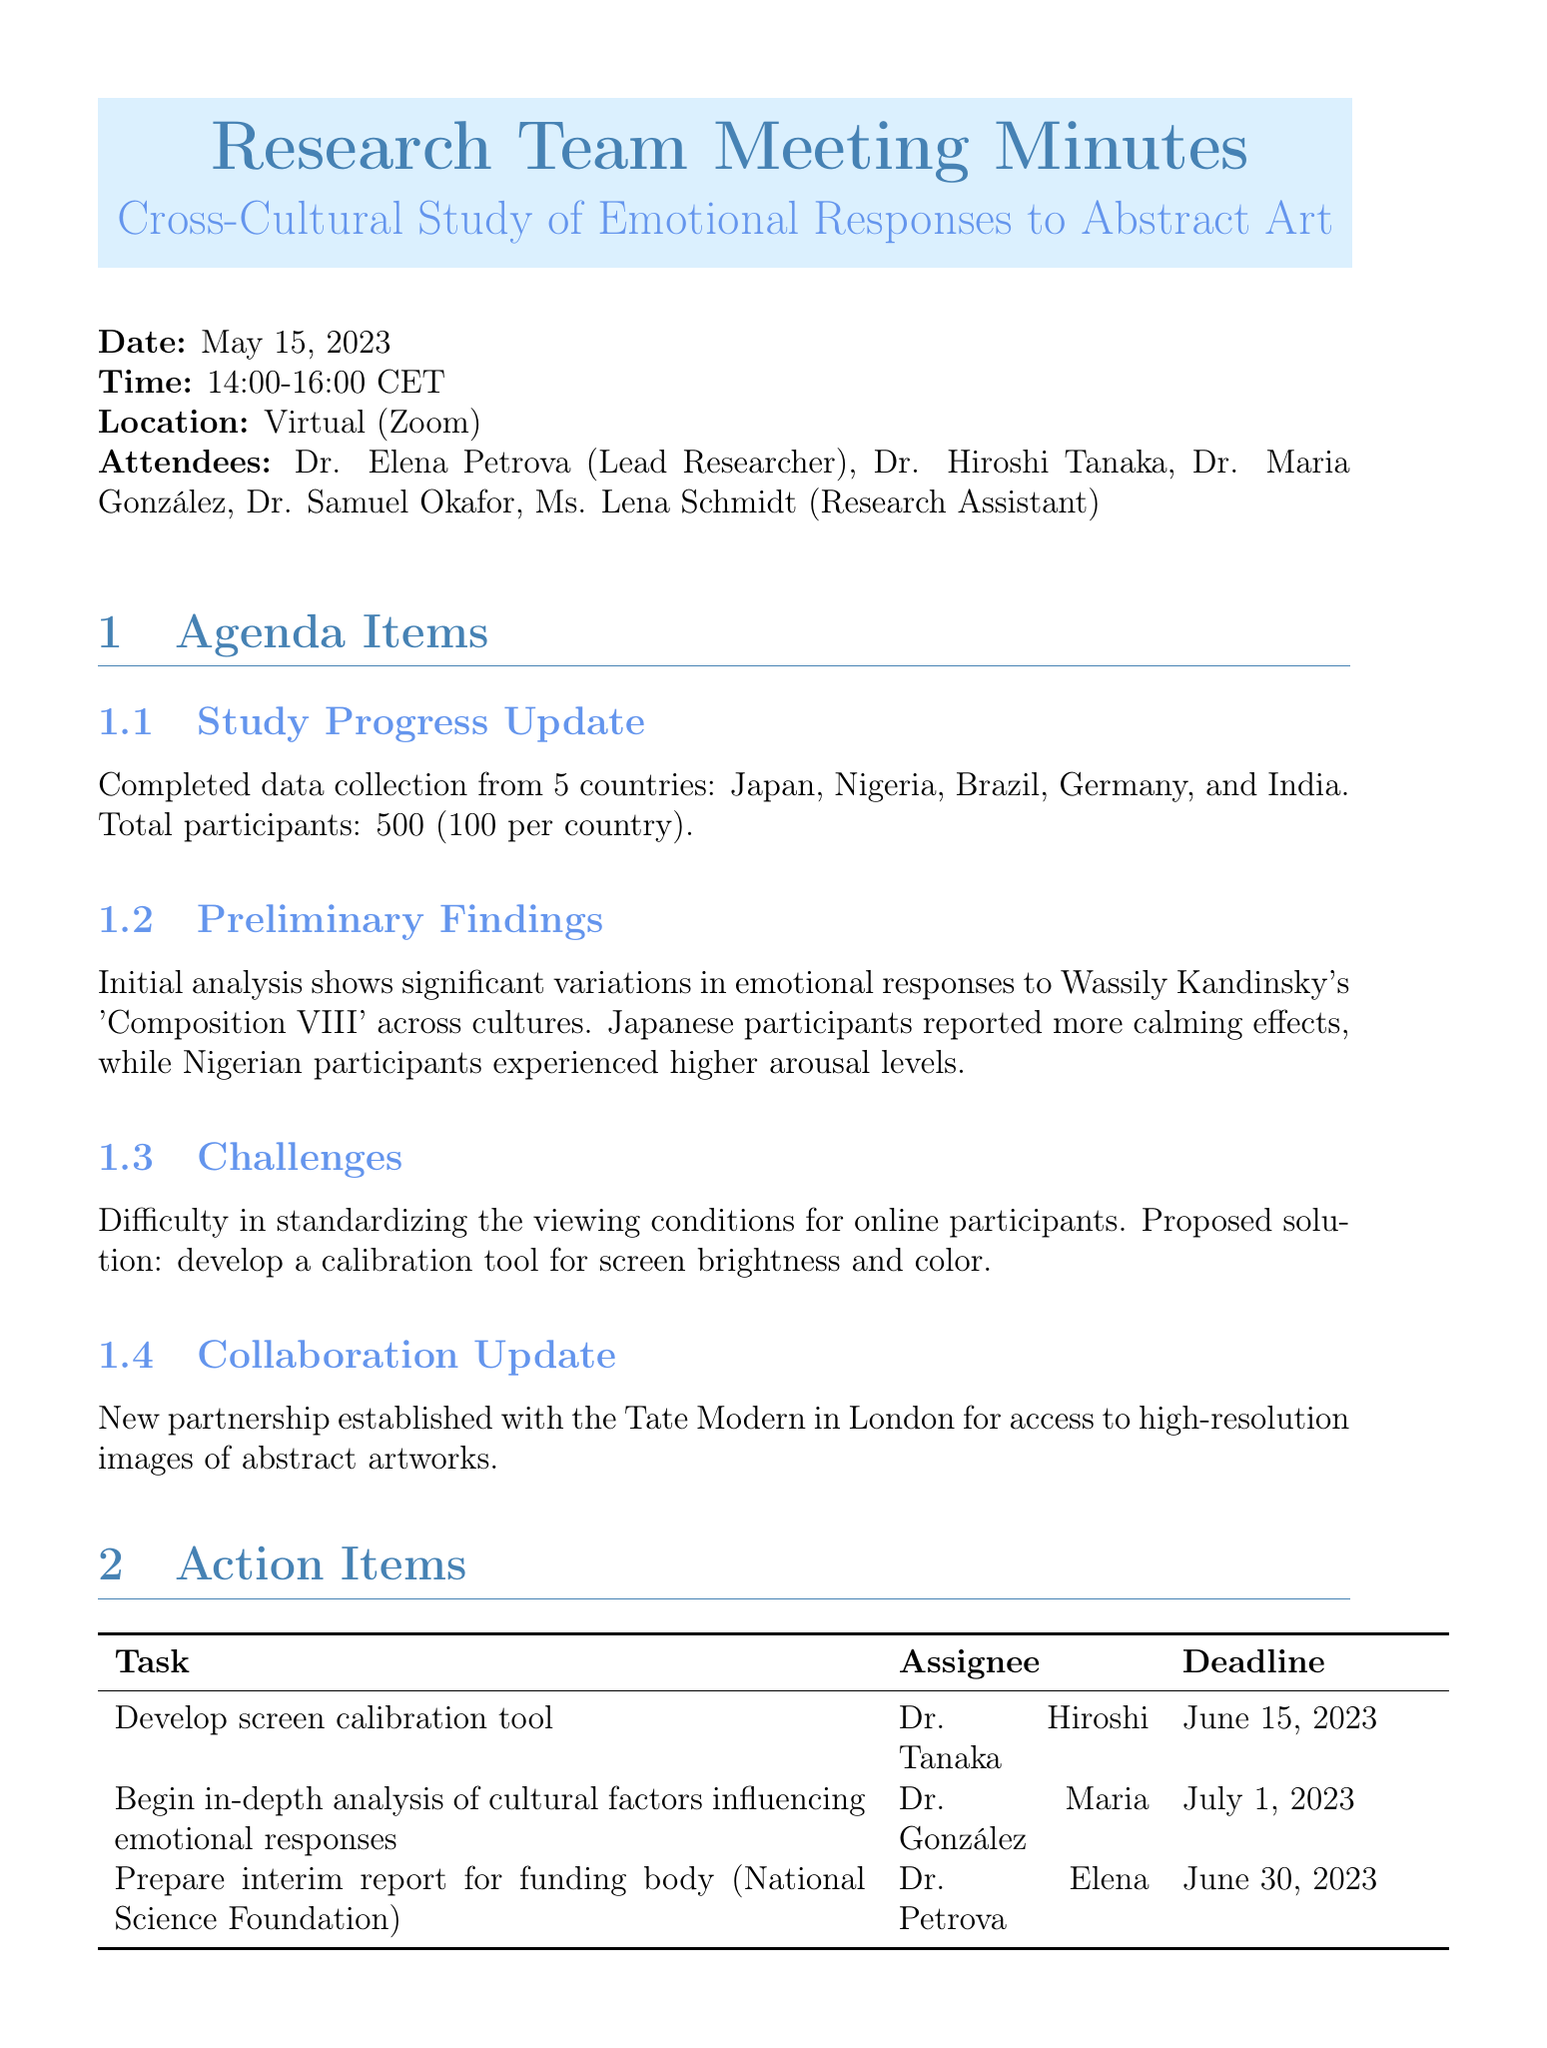What is the date of the meeting? The date of the meeting is provided in the document as May 15, 2023.
Answer: May 15, 2023 Who is the lead researcher? The lead researcher is listed as Dr. Elena Petrova in the attendees section.
Answer: Dr. Elena Petrova How many countries were included in the study? The document states that data was collected from 5 countries.
Answer: 5 What was the total number of participants? The document specifies the total participants as 500, with 100 per country.
Answer: 500 What cultural differences were observed in emotional responses? The preliminary findings indicate Japanese participants reported calming effects while Nigerian participants experienced higher arousal levels.
Answer: Calming effects, higher arousal levels What task is assigned to Dr. Hiroshi Tanaka? According to the action items, Dr. Hiroshi Tanaka is responsible for developing the screen calibration tool.
Answer: Develop screen calibration tool What is the deadline for the preparation of the interim report? The deadline for the interim report for the National Science Foundation is mentioned in the action items section.
Answer: June 30, 2023 When is the next meeting scheduled? The next meeting date is provided in the document as June 12, 2023.
Answer: June 12, 2023 What is the name of the new partnership established? The partnership mentioned in the collaboration update is with the Tate Modern in London.
Answer: Tate Modern 